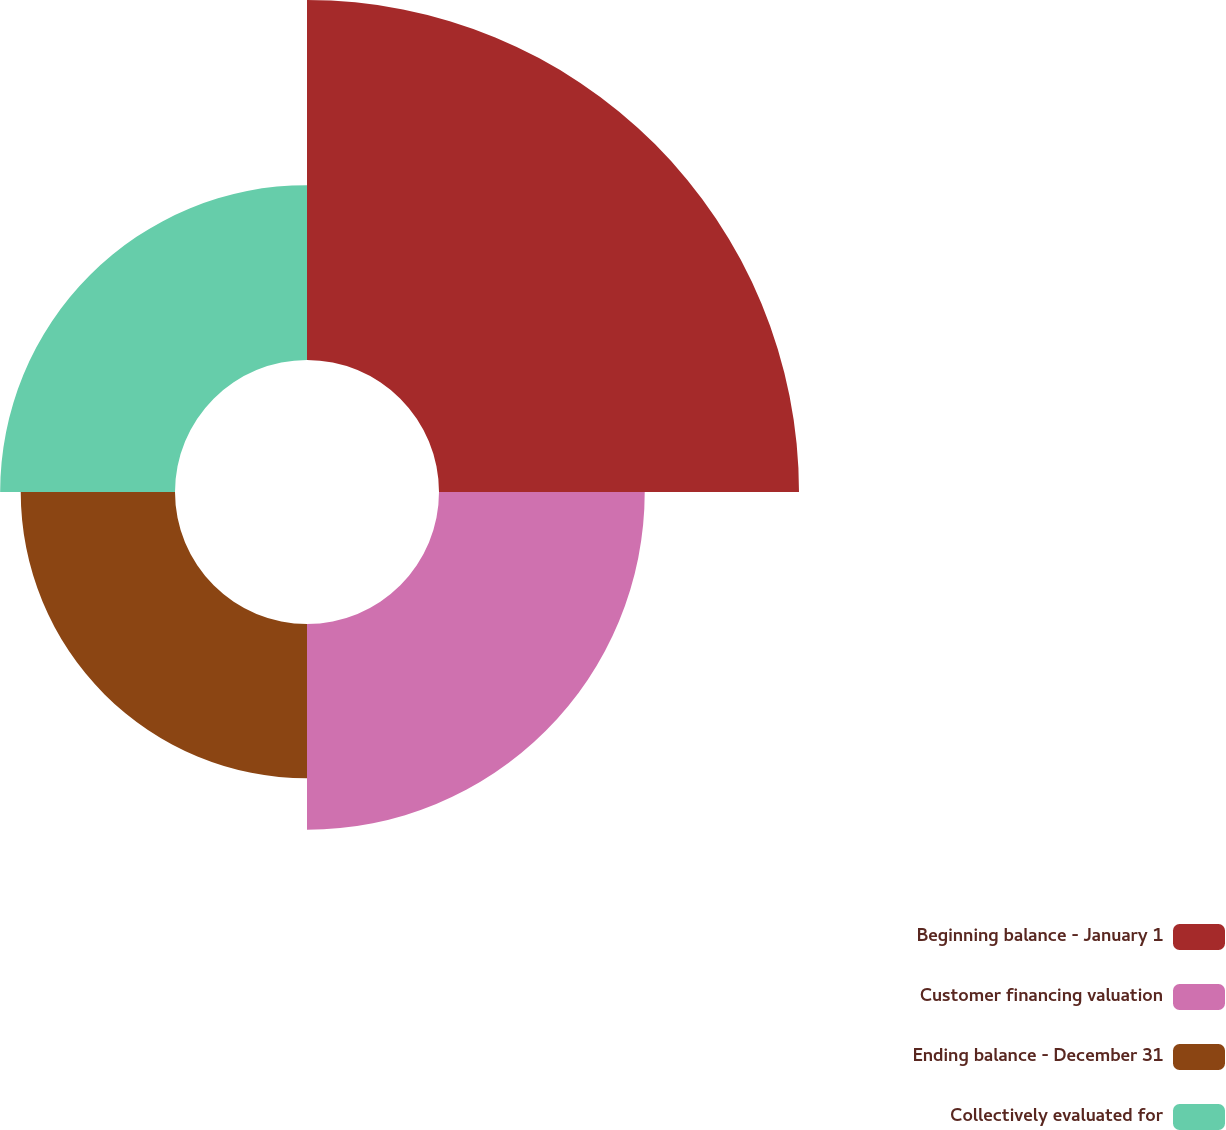Convert chart to OTSL. <chart><loc_0><loc_0><loc_500><loc_500><pie_chart><fcel>Beginning balance - January 1<fcel>Customer financing valuation<fcel>Ending balance - December 31<fcel>Collectively evaluated for<nl><fcel>40.23%<fcel>22.99%<fcel>17.24%<fcel>19.54%<nl></chart> 